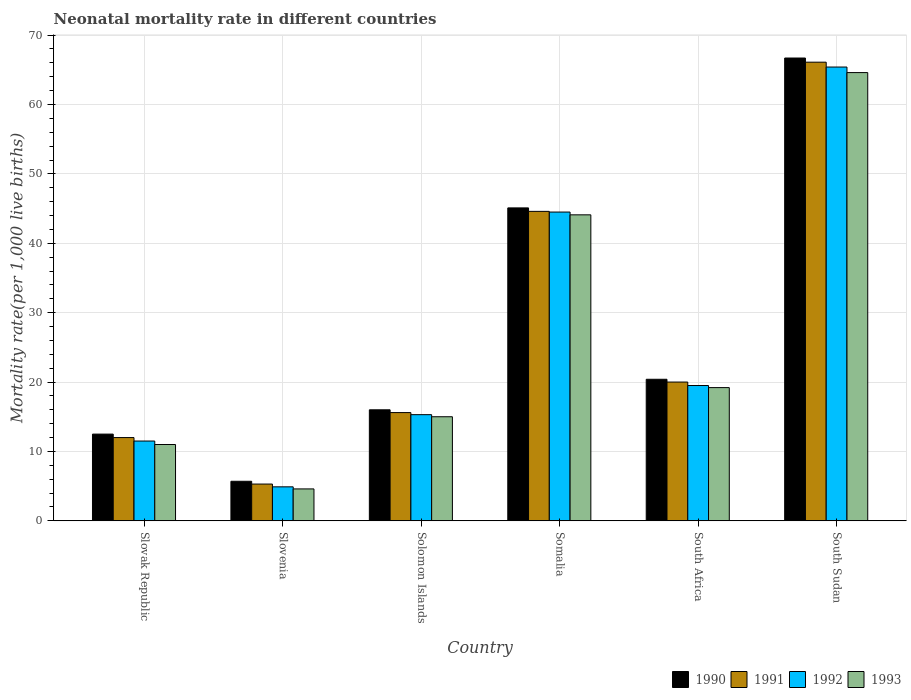How many different coloured bars are there?
Give a very brief answer. 4. Are the number of bars per tick equal to the number of legend labels?
Your answer should be very brief. Yes. How many bars are there on the 2nd tick from the left?
Make the answer very short. 4. How many bars are there on the 6th tick from the right?
Provide a short and direct response. 4. What is the label of the 4th group of bars from the left?
Your answer should be very brief. Somalia. In how many cases, is the number of bars for a given country not equal to the number of legend labels?
Offer a very short reply. 0. Across all countries, what is the maximum neonatal mortality rate in 1990?
Your answer should be very brief. 66.7. Across all countries, what is the minimum neonatal mortality rate in 1993?
Your answer should be compact. 4.6. In which country was the neonatal mortality rate in 1992 maximum?
Your answer should be compact. South Sudan. In which country was the neonatal mortality rate in 1991 minimum?
Offer a very short reply. Slovenia. What is the total neonatal mortality rate in 1990 in the graph?
Ensure brevity in your answer.  166.4. What is the difference between the neonatal mortality rate in 1991 in Slovenia and that in Somalia?
Keep it short and to the point. -39.3. What is the difference between the neonatal mortality rate in 1992 in Slovenia and the neonatal mortality rate in 1991 in South Sudan?
Provide a succinct answer. -61.2. What is the average neonatal mortality rate in 1992 per country?
Give a very brief answer. 26.85. What is the difference between the neonatal mortality rate of/in 1992 and neonatal mortality rate of/in 1990 in South Africa?
Ensure brevity in your answer.  -0.9. In how many countries, is the neonatal mortality rate in 1992 greater than 58?
Offer a terse response. 1. What is the ratio of the neonatal mortality rate in 1991 in Slovak Republic to that in South Sudan?
Ensure brevity in your answer.  0.18. Is the neonatal mortality rate in 1990 in Slovak Republic less than that in Slovenia?
Make the answer very short. No. Is the difference between the neonatal mortality rate in 1992 in South Africa and South Sudan greater than the difference between the neonatal mortality rate in 1990 in South Africa and South Sudan?
Ensure brevity in your answer.  Yes. What is the difference between the highest and the second highest neonatal mortality rate in 1993?
Offer a terse response. 45.4. What is the difference between the highest and the lowest neonatal mortality rate in 1992?
Your answer should be compact. 60.5. Is the sum of the neonatal mortality rate in 1990 in Slovenia and Somalia greater than the maximum neonatal mortality rate in 1991 across all countries?
Keep it short and to the point. No. Is it the case that in every country, the sum of the neonatal mortality rate in 1993 and neonatal mortality rate in 1992 is greater than the sum of neonatal mortality rate in 1991 and neonatal mortality rate in 1990?
Ensure brevity in your answer.  No. Is it the case that in every country, the sum of the neonatal mortality rate in 1990 and neonatal mortality rate in 1993 is greater than the neonatal mortality rate in 1992?
Ensure brevity in your answer.  Yes. Are all the bars in the graph horizontal?
Provide a short and direct response. No. What is the difference between two consecutive major ticks on the Y-axis?
Your answer should be compact. 10. Where does the legend appear in the graph?
Make the answer very short. Bottom right. What is the title of the graph?
Offer a terse response. Neonatal mortality rate in different countries. What is the label or title of the Y-axis?
Your answer should be very brief. Mortality rate(per 1,0 live births). What is the Mortality rate(per 1,000 live births) of 1991 in Slovenia?
Offer a very short reply. 5.3. What is the Mortality rate(per 1,000 live births) of 1992 in Slovenia?
Ensure brevity in your answer.  4.9. What is the Mortality rate(per 1,000 live births) in 1990 in Solomon Islands?
Keep it short and to the point. 16. What is the Mortality rate(per 1,000 live births) of 1990 in Somalia?
Ensure brevity in your answer.  45.1. What is the Mortality rate(per 1,000 live births) of 1991 in Somalia?
Offer a very short reply. 44.6. What is the Mortality rate(per 1,000 live births) in 1992 in Somalia?
Provide a short and direct response. 44.5. What is the Mortality rate(per 1,000 live births) in 1993 in Somalia?
Your answer should be very brief. 44.1. What is the Mortality rate(per 1,000 live births) in 1990 in South Africa?
Make the answer very short. 20.4. What is the Mortality rate(per 1,000 live births) of 1992 in South Africa?
Ensure brevity in your answer.  19.5. What is the Mortality rate(per 1,000 live births) of 1990 in South Sudan?
Keep it short and to the point. 66.7. What is the Mortality rate(per 1,000 live births) of 1991 in South Sudan?
Give a very brief answer. 66.1. What is the Mortality rate(per 1,000 live births) of 1992 in South Sudan?
Offer a very short reply. 65.4. What is the Mortality rate(per 1,000 live births) in 1993 in South Sudan?
Offer a very short reply. 64.6. Across all countries, what is the maximum Mortality rate(per 1,000 live births) of 1990?
Keep it short and to the point. 66.7. Across all countries, what is the maximum Mortality rate(per 1,000 live births) in 1991?
Ensure brevity in your answer.  66.1. Across all countries, what is the maximum Mortality rate(per 1,000 live births) of 1992?
Give a very brief answer. 65.4. Across all countries, what is the maximum Mortality rate(per 1,000 live births) of 1993?
Ensure brevity in your answer.  64.6. Across all countries, what is the minimum Mortality rate(per 1,000 live births) in 1990?
Your answer should be very brief. 5.7. What is the total Mortality rate(per 1,000 live births) of 1990 in the graph?
Give a very brief answer. 166.4. What is the total Mortality rate(per 1,000 live births) of 1991 in the graph?
Make the answer very short. 163.6. What is the total Mortality rate(per 1,000 live births) of 1992 in the graph?
Offer a very short reply. 161.1. What is the total Mortality rate(per 1,000 live births) in 1993 in the graph?
Provide a succinct answer. 158.5. What is the difference between the Mortality rate(per 1,000 live births) in 1990 in Slovak Republic and that in Slovenia?
Provide a succinct answer. 6.8. What is the difference between the Mortality rate(per 1,000 live births) of 1990 in Slovak Republic and that in Somalia?
Your answer should be compact. -32.6. What is the difference between the Mortality rate(per 1,000 live births) of 1991 in Slovak Republic and that in Somalia?
Your response must be concise. -32.6. What is the difference between the Mortality rate(per 1,000 live births) in 1992 in Slovak Republic and that in Somalia?
Provide a short and direct response. -33. What is the difference between the Mortality rate(per 1,000 live births) in 1993 in Slovak Republic and that in Somalia?
Offer a terse response. -33.1. What is the difference between the Mortality rate(per 1,000 live births) of 1993 in Slovak Republic and that in South Africa?
Your answer should be very brief. -8.2. What is the difference between the Mortality rate(per 1,000 live births) in 1990 in Slovak Republic and that in South Sudan?
Make the answer very short. -54.2. What is the difference between the Mortality rate(per 1,000 live births) of 1991 in Slovak Republic and that in South Sudan?
Offer a terse response. -54.1. What is the difference between the Mortality rate(per 1,000 live births) in 1992 in Slovak Republic and that in South Sudan?
Your answer should be compact. -53.9. What is the difference between the Mortality rate(per 1,000 live births) in 1993 in Slovak Republic and that in South Sudan?
Give a very brief answer. -53.6. What is the difference between the Mortality rate(per 1,000 live births) in 1991 in Slovenia and that in Solomon Islands?
Ensure brevity in your answer.  -10.3. What is the difference between the Mortality rate(per 1,000 live births) of 1993 in Slovenia and that in Solomon Islands?
Provide a short and direct response. -10.4. What is the difference between the Mortality rate(per 1,000 live births) of 1990 in Slovenia and that in Somalia?
Provide a short and direct response. -39.4. What is the difference between the Mortality rate(per 1,000 live births) of 1991 in Slovenia and that in Somalia?
Your answer should be very brief. -39.3. What is the difference between the Mortality rate(per 1,000 live births) of 1992 in Slovenia and that in Somalia?
Provide a short and direct response. -39.6. What is the difference between the Mortality rate(per 1,000 live births) in 1993 in Slovenia and that in Somalia?
Your response must be concise. -39.5. What is the difference between the Mortality rate(per 1,000 live births) of 1990 in Slovenia and that in South Africa?
Give a very brief answer. -14.7. What is the difference between the Mortality rate(per 1,000 live births) of 1991 in Slovenia and that in South Africa?
Give a very brief answer. -14.7. What is the difference between the Mortality rate(per 1,000 live births) of 1992 in Slovenia and that in South Africa?
Make the answer very short. -14.6. What is the difference between the Mortality rate(per 1,000 live births) of 1993 in Slovenia and that in South Africa?
Offer a terse response. -14.6. What is the difference between the Mortality rate(per 1,000 live births) in 1990 in Slovenia and that in South Sudan?
Offer a very short reply. -61. What is the difference between the Mortality rate(per 1,000 live births) in 1991 in Slovenia and that in South Sudan?
Keep it short and to the point. -60.8. What is the difference between the Mortality rate(per 1,000 live births) in 1992 in Slovenia and that in South Sudan?
Ensure brevity in your answer.  -60.5. What is the difference between the Mortality rate(per 1,000 live births) of 1993 in Slovenia and that in South Sudan?
Ensure brevity in your answer.  -60. What is the difference between the Mortality rate(per 1,000 live births) in 1990 in Solomon Islands and that in Somalia?
Your response must be concise. -29.1. What is the difference between the Mortality rate(per 1,000 live births) in 1992 in Solomon Islands and that in Somalia?
Provide a short and direct response. -29.2. What is the difference between the Mortality rate(per 1,000 live births) in 1993 in Solomon Islands and that in Somalia?
Offer a terse response. -29.1. What is the difference between the Mortality rate(per 1,000 live births) of 1991 in Solomon Islands and that in South Africa?
Offer a terse response. -4.4. What is the difference between the Mortality rate(per 1,000 live births) of 1992 in Solomon Islands and that in South Africa?
Offer a very short reply. -4.2. What is the difference between the Mortality rate(per 1,000 live births) of 1993 in Solomon Islands and that in South Africa?
Offer a terse response. -4.2. What is the difference between the Mortality rate(per 1,000 live births) in 1990 in Solomon Islands and that in South Sudan?
Offer a very short reply. -50.7. What is the difference between the Mortality rate(per 1,000 live births) of 1991 in Solomon Islands and that in South Sudan?
Your answer should be very brief. -50.5. What is the difference between the Mortality rate(per 1,000 live births) in 1992 in Solomon Islands and that in South Sudan?
Your answer should be compact. -50.1. What is the difference between the Mortality rate(per 1,000 live births) of 1993 in Solomon Islands and that in South Sudan?
Provide a succinct answer. -49.6. What is the difference between the Mortality rate(per 1,000 live births) of 1990 in Somalia and that in South Africa?
Your answer should be very brief. 24.7. What is the difference between the Mortality rate(per 1,000 live births) in 1991 in Somalia and that in South Africa?
Keep it short and to the point. 24.6. What is the difference between the Mortality rate(per 1,000 live births) of 1993 in Somalia and that in South Africa?
Make the answer very short. 24.9. What is the difference between the Mortality rate(per 1,000 live births) in 1990 in Somalia and that in South Sudan?
Offer a terse response. -21.6. What is the difference between the Mortality rate(per 1,000 live births) of 1991 in Somalia and that in South Sudan?
Make the answer very short. -21.5. What is the difference between the Mortality rate(per 1,000 live births) in 1992 in Somalia and that in South Sudan?
Offer a very short reply. -20.9. What is the difference between the Mortality rate(per 1,000 live births) of 1993 in Somalia and that in South Sudan?
Make the answer very short. -20.5. What is the difference between the Mortality rate(per 1,000 live births) of 1990 in South Africa and that in South Sudan?
Make the answer very short. -46.3. What is the difference between the Mortality rate(per 1,000 live births) of 1991 in South Africa and that in South Sudan?
Keep it short and to the point. -46.1. What is the difference between the Mortality rate(per 1,000 live births) of 1992 in South Africa and that in South Sudan?
Ensure brevity in your answer.  -45.9. What is the difference between the Mortality rate(per 1,000 live births) in 1993 in South Africa and that in South Sudan?
Your answer should be compact. -45.4. What is the difference between the Mortality rate(per 1,000 live births) in 1990 in Slovak Republic and the Mortality rate(per 1,000 live births) in 1992 in Slovenia?
Provide a short and direct response. 7.6. What is the difference between the Mortality rate(per 1,000 live births) in 1991 in Slovak Republic and the Mortality rate(per 1,000 live births) in 1992 in Slovenia?
Provide a short and direct response. 7.1. What is the difference between the Mortality rate(per 1,000 live births) in 1991 in Slovak Republic and the Mortality rate(per 1,000 live births) in 1993 in Slovenia?
Provide a succinct answer. 7.4. What is the difference between the Mortality rate(per 1,000 live births) of 1990 in Slovak Republic and the Mortality rate(per 1,000 live births) of 1991 in Solomon Islands?
Offer a terse response. -3.1. What is the difference between the Mortality rate(per 1,000 live births) of 1990 in Slovak Republic and the Mortality rate(per 1,000 live births) of 1992 in Solomon Islands?
Offer a terse response. -2.8. What is the difference between the Mortality rate(per 1,000 live births) in 1991 in Slovak Republic and the Mortality rate(per 1,000 live births) in 1992 in Solomon Islands?
Your response must be concise. -3.3. What is the difference between the Mortality rate(per 1,000 live births) in 1991 in Slovak Republic and the Mortality rate(per 1,000 live births) in 1993 in Solomon Islands?
Ensure brevity in your answer.  -3. What is the difference between the Mortality rate(per 1,000 live births) of 1992 in Slovak Republic and the Mortality rate(per 1,000 live births) of 1993 in Solomon Islands?
Your answer should be compact. -3.5. What is the difference between the Mortality rate(per 1,000 live births) in 1990 in Slovak Republic and the Mortality rate(per 1,000 live births) in 1991 in Somalia?
Your response must be concise. -32.1. What is the difference between the Mortality rate(per 1,000 live births) in 1990 in Slovak Republic and the Mortality rate(per 1,000 live births) in 1992 in Somalia?
Keep it short and to the point. -32. What is the difference between the Mortality rate(per 1,000 live births) of 1990 in Slovak Republic and the Mortality rate(per 1,000 live births) of 1993 in Somalia?
Provide a succinct answer. -31.6. What is the difference between the Mortality rate(per 1,000 live births) of 1991 in Slovak Republic and the Mortality rate(per 1,000 live births) of 1992 in Somalia?
Provide a succinct answer. -32.5. What is the difference between the Mortality rate(per 1,000 live births) in 1991 in Slovak Republic and the Mortality rate(per 1,000 live births) in 1993 in Somalia?
Offer a very short reply. -32.1. What is the difference between the Mortality rate(per 1,000 live births) of 1992 in Slovak Republic and the Mortality rate(per 1,000 live births) of 1993 in Somalia?
Give a very brief answer. -32.6. What is the difference between the Mortality rate(per 1,000 live births) in 1990 in Slovak Republic and the Mortality rate(per 1,000 live births) in 1992 in South Africa?
Offer a terse response. -7. What is the difference between the Mortality rate(per 1,000 live births) in 1990 in Slovak Republic and the Mortality rate(per 1,000 live births) in 1991 in South Sudan?
Ensure brevity in your answer.  -53.6. What is the difference between the Mortality rate(per 1,000 live births) in 1990 in Slovak Republic and the Mortality rate(per 1,000 live births) in 1992 in South Sudan?
Give a very brief answer. -52.9. What is the difference between the Mortality rate(per 1,000 live births) of 1990 in Slovak Republic and the Mortality rate(per 1,000 live births) of 1993 in South Sudan?
Make the answer very short. -52.1. What is the difference between the Mortality rate(per 1,000 live births) in 1991 in Slovak Republic and the Mortality rate(per 1,000 live births) in 1992 in South Sudan?
Offer a terse response. -53.4. What is the difference between the Mortality rate(per 1,000 live births) in 1991 in Slovak Republic and the Mortality rate(per 1,000 live births) in 1993 in South Sudan?
Ensure brevity in your answer.  -52.6. What is the difference between the Mortality rate(per 1,000 live births) in 1992 in Slovak Republic and the Mortality rate(per 1,000 live births) in 1993 in South Sudan?
Provide a short and direct response. -53.1. What is the difference between the Mortality rate(per 1,000 live births) of 1990 in Slovenia and the Mortality rate(per 1,000 live births) of 1993 in Solomon Islands?
Offer a very short reply. -9.3. What is the difference between the Mortality rate(per 1,000 live births) in 1991 in Slovenia and the Mortality rate(per 1,000 live births) in 1992 in Solomon Islands?
Your answer should be very brief. -10. What is the difference between the Mortality rate(per 1,000 live births) in 1992 in Slovenia and the Mortality rate(per 1,000 live births) in 1993 in Solomon Islands?
Your answer should be compact. -10.1. What is the difference between the Mortality rate(per 1,000 live births) in 1990 in Slovenia and the Mortality rate(per 1,000 live births) in 1991 in Somalia?
Your response must be concise. -38.9. What is the difference between the Mortality rate(per 1,000 live births) in 1990 in Slovenia and the Mortality rate(per 1,000 live births) in 1992 in Somalia?
Your answer should be very brief. -38.8. What is the difference between the Mortality rate(per 1,000 live births) of 1990 in Slovenia and the Mortality rate(per 1,000 live births) of 1993 in Somalia?
Ensure brevity in your answer.  -38.4. What is the difference between the Mortality rate(per 1,000 live births) of 1991 in Slovenia and the Mortality rate(per 1,000 live births) of 1992 in Somalia?
Your response must be concise. -39.2. What is the difference between the Mortality rate(per 1,000 live births) of 1991 in Slovenia and the Mortality rate(per 1,000 live births) of 1993 in Somalia?
Provide a short and direct response. -38.8. What is the difference between the Mortality rate(per 1,000 live births) in 1992 in Slovenia and the Mortality rate(per 1,000 live births) in 1993 in Somalia?
Your answer should be compact. -39.2. What is the difference between the Mortality rate(per 1,000 live births) of 1990 in Slovenia and the Mortality rate(per 1,000 live births) of 1991 in South Africa?
Offer a very short reply. -14.3. What is the difference between the Mortality rate(per 1,000 live births) of 1991 in Slovenia and the Mortality rate(per 1,000 live births) of 1993 in South Africa?
Your answer should be compact. -13.9. What is the difference between the Mortality rate(per 1,000 live births) of 1992 in Slovenia and the Mortality rate(per 1,000 live births) of 1993 in South Africa?
Offer a terse response. -14.3. What is the difference between the Mortality rate(per 1,000 live births) of 1990 in Slovenia and the Mortality rate(per 1,000 live births) of 1991 in South Sudan?
Your answer should be very brief. -60.4. What is the difference between the Mortality rate(per 1,000 live births) in 1990 in Slovenia and the Mortality rate(per 1,000 live births) in 1992 in South Sudan?
Keep it short and to the point. -59.7. What is the difference between the Mortality rate(per 1,000 live births) of 1990 in Slovenia and the Mortality rate(per 1,000 live births) of 1993 in South Sudan?
Provide a short and direct response. -58.9. What is the difference between the Mortality rate(per 1,000 live births) of 1991 in Slovenia and the Mortality rate(per 1,000 live births) of 1992 in South Sudan?
Ensure brevity in your answer.  -60.1. What is the difference between the Mortality rate(per 1,000 live births) in 1991 in Slovenia and the Mortality rate(per 1,000 live births) in 1993 in South Sudan?
Make the answer very short. -59.3. What is the difference between the Mortality rate(per 1,000 live births) in 1992 in Slovenia and the Mortality rate(per 1,000 live births) in 1993 in South Sudan?
Ensure brevity in your answer.  -59.7. What is the difference between the Mortality rate(per 1,000 live births) of 1990 in Solomon Islands and the Mortality rate(per 1,000 live births) of 1991 in Somalia?
Keep it short and to the point. -28.6. What is the difference between the Mortality rate(per 1,000 live births) in 1990 in Solomon Islands and the Mortality rate(per 1,000 live births) in 1992 in Somalia?
Your response must be concise. -28.5. What is the difference between the Mortality rate(per 1,000 live births) of 1990 in Solomon Islands and the Mortality rate(per 1,000 live births) of 1993 in Somalia?
Ensure brevity in your answer.  -28.1. What is the difference between the Mortality rate(per 1,000 live births) in 1991 in Solomon Islands and the Mortality rate(per 1,000 live births) in 1992 in Somalia?
Your answer should be compact. -28.9. What is the difference between the Mortality rate(per 1,000 live births) of 1991 in Solomon Islands and the Mortality rate(per 1,000 live births) of 1993 in Somalia?
Make the answer very short. -28.5. What is the difference between the Mortality rate(per 1,000 live births) of 1992 in Solomon Islands and the Mortality rate(per 1,000 live births) of 1993 in Somalia?
Offer a terse response. -28.8. What is the difference between the Mortality rate(per 1,000 live births) of 1990 in Solomon Islands and the Mortality rate(per 1,000 live births) of 1991 in South Africa?
Keep it short and to the point. -4. What is the difference between the Mortality rate(per 1,000 live births) in 1990 in Solomon Islands and the Mortality rate(per 1,000 live births) in 1992 in South Africa?
Provide a short and direct response. -3.5. What is the difference between the Mortality rate(per 1,000 live births) of 1991 in Solomon Islands and the Mortality rate(per 1,000 live births) of 1992 in South Africa?
Your answer should be very brief. -3.9. What is the difference between the Mortality rate(per 1,000 live births) of 1991 in Solomon Islands and the Mortality rate(per 1,000 live births) of 1993 in South Africa?
Offer a terse response. -3.6. What is the difference between the Mortality rate(per 1,000 live births) of 1990 in Solomon Islands and the Mortality rate(per 1,000 live births) of 1991 in South Sudan?
Give a very brief answer. -50.1. What is the difference between the Mortality rate(per 1,000 live births) in 1990 in Solomon Islands and the Mortality rate(per 1,000 live births) in 1992 in South Sudan?
Ensure brevity in your answer.  -49.4. What is the difference between the Mortality rate(per 1,000 live births) of 1990 in Solomon Islands and the Mortality rate(per 1,000 live births) of 1993 in South Sudan?
Provide a short and direct response. -48.6. What is the difference between the Mortality rate(per 1,000 live births) of 1991 in Solomon Islands and the Mortality rate(per 1,000 live births) of 1992 in South Sudan?
Give a very brief answer. -49.8. What is the difference between the Mortality rate(per 1,000 live births) in 1991 in Solomon Islands and the Mortality rate(per 1,000 live births) in 1993 in South Sudan?
Give a very brief answer. -49. What is the difference between the Mortality rate(per 1,000 live births) of 1992 in Solomon Islands and the Mortality rate(per 1,000 live births) of 1993 in South Sudan?
Your response must be concise. -49.3. What is the difference between the Mortality rate(per 1,000 live births) of 1990 in Somalia and the Mortality rate(per 1,000 live births) of 1991 in South Africa?
Give a very brief answer. 25.1. What is the difference between the Mortality rate(per 1,000 live births) in 1990 in Somalia and the Mortality rate(per 1,000 live births) in 1992 in South Africa?
Your answer should be compact. 25.6. What is the difference between the Mortality rate(per 1,000 live births) of 1990 in Somalia and the Mortality rate(per 1,000 live births) of 1993 in South Africa?
Your answer should be very brief. 25.9. What is the difference between the Mortality rate(per 1,000 live births) in 1991 in Somalia and the Mortality rate(per 1,000 live births) in 1992 in South Africa?
Your response must be concise. 25.1. What is the difference between the Mortality rate(per 1,000 live births) in 1991 in Somalia and the Mortality rate(per 1,000 live births) in 1993 in South Africa?
Offer a terse response. 25.4. What is the difference between the Mortality rate(per 1,000 live births) of 1992 in Somalia and the Mortality rate(per 1,000 live births) of 1993 in South Africa?
Give a very brief answer. 25.3. What is the difference between the Mortality rate(per 1,000 live births) in 1990 in Somalia and the Mortality rate(per 1,000 live births) in 1992 in South Sudan?
Provide a short and direct response. -20.3. What is the difference between the Mortality rate(per 1,000 live births) in 1990 in Somalia and the Mortality rate(per 1,000 live births) in 1993 in South Sudan?
Provide a succinct answer. -19.5. What is the difference between the Mortality rate(per 1,000 live births) of 1991 in Somalia and the Mortality rate(per 1,000 live births) of 1992 in South Sudan?
Provide a succinct answer. -20.8. What is the difference between the Mortality rate(per 1,000 live births) of 1991 in Somalia and the Mortality rate(per 1,000 live births) of 1993 in South Sudan?
Keep it short and to the point. -20. What is the difference between the Mortality rate(per 1,000 live births) in 1992 in Somalia and the Mortality rate(per 1,000 live births) in 1993 in South Sudan?
Provide a short and direct response. -20.1. What is the difference between the Mortality rate(per 1,000 live births) in 1990 in South Africa and the Mortality rate(per 1,000 live births) in 1991 in South Sudan?
Offer a very short reply. -45.7. What is the difference between the Mortality rate(per 1,000 live births) of 1990 in South Africa and the Mortality rate(per 1,000 live births) of 1992 in South Sudan?
Your response must be concise. -45. What is the difference between the Mortality rate(per 1,000 live births) of 1990 in South Africa and the Mortality rate(per 1,000 live births) of 1993 in South Sudan?
Keep it short and to the point. -44.2. What is the difference between the Mortality rate(per 1,000 live births) in 1991 in South Africa and the Mortality rate(per 1,000 live births) in 1992 in South Sudan?
Ensure brevity in your answer.  -45.4. What is the difference between the Mortality rate(per 1,000 live births) in 1991 in South Africa and the Mortality rate(per 1,000 live births) in 1993 in South Sudan?
Provide a short and direct response. -44.6. What is the difference between the Mortality rate(per 1,000 live births) of 1992 in South Africa and the Mortality rate(per 1,000 live births) of 1993 in South Sudan?
Keep it short and to the point. -45.1. What is the average Mortality rate(per 1,000 live births) in 1990 per country?
Your response must be concise. 27.73. What is the average Mortality rate(per 1,000 live births) of 1991 per country?
Provide a succinct answer. 27.27. What is the average Mortality rate(per 1,000 live births) of 1992 per country?
Your response must be concise. 26.85. What is the average Mortality rate(per 1,000 live births) in 1993 per country?
Your response must be concise. 26.42. What is the difference between the Mortality rate(per 1,000 live births) in 1990 and Mortality rate(per 1,000 live births) in 1991 in Slovak Republic?
Your answer should be very brief. 0.5. What is the difference between the Mortality rate(per 1,000 live births) in 1990 and Mortality rate(per 1,000 live births) in 1992 in Slovak Republic?
Provide a short and direct response. 1. What is the difference between the Mortality rate(per 1,000 live births) in 1991 and Mortality rate(per 1,000 live births) in 1992 in Slovak Republic?
Offer a terse response. 0.5. What is the difference between the Mortality rate(per 1,000 live births) in 1991 and Mortality rate(per 1,000 live births) in 1993 in Slovak Republic?
Ensure brevity in your answer.  1. What is the difference between the Mortality rate(per 1,000 live births) in 1990 and Mortality rate(per 1,000 live births) in 1991 in Slovenia?
Your response must be concise. 0.4. What is the difference between the Mortality rate(per 1,000 live births) in 1991 and Mortality rate(per 1,000 live births) in 1992 in Slovenia?
Make the answer very short. 0.4. What is the difference between the Mortality rate(per 1,000 live births) of 1991 and Mortality rate(per 1,000 live births) of 1993 in Slovenia?
Make the answer very short. 0.7. What is the difference between the Mortality rate(per 1,000 live births) of 1990 and Mortality rate(per 1,000 live births) of 1991 in Solomon Islands?
Give a very brief answer. 0.4. What is the difference between the Mortality rate(per 1,000 live births) of 1991 and Mortality rate(per 1,000 live births) of 1992 in Solomon Islands?
Provide a short and direct response. 0.3. What is the difference between the Mortality rate(per 1,000 live births) of 1990 and Mortality rate(per 1,000 live births) of 1991 in Somalia?
Offer a terse response. 0.5. What is the difference between the Mortality rate(per 1,000 live births) of 1990 and Mortality rate(per 1,000 live births) of 1992 in Somalia?
Give a very brief answer. 0.6. What is the difference between the Mortality rate(per 1,000 live births) of 1990 and Mortality rate(per 1,000 live births) of 1993 in Somalia?
Your answer should be compact. 1. What is the difference between the Mortality rate(per 1,000 live births) in 1991 and Mortality rate(per 1,000 live births) in 1992 in Somalia?
Make the answer very short. 0.1. What is the difference between the Mortality rate(per 1,000 live births) in 1991 and Mortality rate(per 1,000 live births) in 1993 in Somalia?
Your response must be concise. 0.5. What is the difference between the Mortality rate(per 1,000 live births) in 1990 and Mortality rate(per 1,000 live births) in 1992 in South Africa?
Provide a short and direct response. 0.9. What is the difference between the Mortality rate(per 1,000 live births) of 1992 and Mortality rate(per 1,000 live births) of 1993 in South Africa?
Your response must be concise. 0.3. What is the difference between the Mortality rate(per 1,000 live births) of 1990 and Mortality rate(per 1,000 live births) of 1991 in South Sudan?
Provide a short and direct response. 0.6. What is the difference between the Mortality rate(per 1,000 live births) of 1990 and Mortality rate(per 1,000 live births) of 1993 in South Sudan?
Keep it short and to the point. 2.1. What is the difference between the Mortality rate(per 1,000 live births) in 1991 and Mortality rate(per 1,000 live births) in 1992 in South Sudan?
Provide a succinct answer. 0.7. What is the difference between the Mortality rate(per 1,000 live births) of 1992 and Mortality rate(per 1,000 live births) of 1993 in South Sudan?
Give a very brief answer. 0.8. What is the ratio of the Mortality rate(per 1,000 live births) of 1990 in Slovak Republic to that in Slovenia?
Offer a terse response. 2.19. What is the ratio of the Mortality rate(per 1,000 live births) in 1991 in Slovak Republic to that in Slovenia?
Keep it short and to the point. 2.26. What is the ratio of the Mortality rate(per 1,000 live births) in 1992 in Slovak Republic to that in Slovenia?
Offer a terse response. 2.35. What is the ratio of the Mortality rate(per 1,000 live births) in 1993 in Slovak Republic to that in Slovenia?
Keep it short and to the point. 2.39. What is the ratio of the Mortality rate(per 1,000 live births) in 1990 in Slovak Republic to that in Solomon Islands?
Your answer should be compact. 0.78. What is the ratio of the Mortality rate(per 1,000 live births) in 1991 in Slovak Republic to that in Solomon Islands?
Your answer should be very brief. 0.77. What is the ratio of the Mortality rate(per 1,000 live births) in 1992 in Slovak Republic to that in Solomon Islands?
Your answer should be compact. 0.75. What is the ratio of the Mortality rate(per 1,000 live births) in 1993 in Slovak Republic to that in Solomon Islands?
Offer a very short reply. 0.73. What is the ratio of the Mortality rate(per 1,000 live births) in 1990 in Slovak Republic to that in Somalia?
Ensure brevity in your answer.  0.28. What is the ratio of the Mortality rate(per 1,000 live births) in 1991 in Slovak Republic to that in Somalia?
Your answer should be compact. 0.27. What is the ratio of the Mortality rate(per 1,000 live births) in 1992 in Slovak Republic to that in Somalia?
Give a very brief answer. 0.26. What is the ratio of the Mortality rate(per 1,000 live births) of 1993 in Slovak Republic to that in Somalia?
Provide a succinct answer. 0.25. What is the ratio of the Mortality rate(per 1,000 live births) of 1990 in Slovak Republic to that in South Africa?
Keep it short and to the point. 0.61. What is the ratio of the Mortality rate(per 1,000 live births) of 1992 in Slovak Republic to that in South Africa?
Provide a succinct answer. 0.59. What is the ratio of the Mortality rate(per 1,000 live births) in 1993 in Slovak Republic to that in South Africa?
Offer a terse response. 0.57. What is the ratio of the Mortality rate(per 1,000 live births) of 1990 in Slovak Republic to that in South Sudan?
Give a very brief answer. 0.19. What is the ratio of the Mortality rate(per 1,000 live births) in 1991 in Slovak Republic to that in South Sudan?
Give a very brief answer. 0.18. What is the ratio of the Mortality rate(per 1,000 live births) in 1992 in Slovak Republic to that in South Sudan?
Your response must be concise. 0.18. What is the ratio of the Mortality rate(per 1,000 live births) in 1993 in Slovak Republic to that in South Sudan?
Offer a terse response. 0.17. What is the ratio of the Mortality rate(per 1,000 live births) of 1990 in Slovenia to that in Solomon Islands?
Give a very brief answer. 0.36. What is the ratio of the Mortality rate(per 1,000 live births) in 1991 in Slovenia to that in Solomon Islands?
Your response must be concise. 0.34. What is the ratio of the Mortality rate(per 1,000 live births) in 1992 in Slovenia to that in Solomon Islands?
Make the answer very short. 0.32. What is the ratio of the Mortality rate(per 1,000 live births) in 1993 in Slovenia to that in Solomon Islands?
Your answer should be very brief. 0.31. What is the ratio of the Mortality rate(per 1,000 live births) of 1990 in Slovenia to that in Somalia?
Provide a short and direct response. 0.13. What is the ratio of the Mortality rate(per 1,000 live births) in 1991 in Slovenia to that in Somalia?
Ensure brevity in your answer.  0.12. What is the ratio of the Mortality rate(per 1,000 live births) of 1992 in Slovenia to that in Somalia?
Provide a short and direct response. 0.11. What is the ratio of the Mortality rate(per 1,000 live births) of 1993 in Slovenia to that in Somalia?
Provide a short and direct response. 0.1. What is the ratio of the Mortality rate(per 1,000 live births) in 1990 in Slovenia to that in South Africa?
Give a very brief answer. 0.28. What is the ratio of the Mortality rate(per 1,000 live births) of 1991 in Slovenia to that in South Africa?
Provide a succinct answer. 0.27. What is the ratio of the Mortality rate(per 1,000 live births) of 1992 in Slovenia to that in South Africa?
Provide a succinct answer. 0.25. What is the ratio of the Mortality rate(per 1,000 live births) in 1993 in Slovenia to that in South Africa?
Ensure brevity in your answer.  0.24. What is the ratio of the Mortality rate(per 1,000 live births) of 1990 in Slovenia to that in South Sudan?
Offer a terse response. 0.09. What is the ratio of the Mortality rate(per 1,000 live births) of 1991 in Slovenia to that in South Sudan?
Provide a short and direct response. 0.08. What is the ratio of the Mortality rate(per 1,000 live births) in 1992 in Slovenia to that in South Sudan?
Offer a very short reply. 0.07. What is the ratio of the Mortality rate(per 1,000 live births) in 1993 in Slovenia to that in South Sudan?
Ensure brevity in your answer.  0.07. What is the ratio of the Mortality rate(per 1,000 live births) of 1990 in Solomon Islands to that in Somalia?
Your answer should be compact. 0.35. What is the ratio of the Mortality rate(per 1,000 live births) in 1991 in Solomon Islands to that in Somalia?
Your answer should be very brief. 0.35. What is the ratio of the Mortality rate(per 1,000 live births) in 1992 in Solomon Islands to that in Somalia?
Your answer should be compact. 0.34. What is the ratio of the Mortality rate(per 1,000 live births) in 1993 in Solomon Islands to that in Somalia?
Your answer should be very brief. 0.34. What is the ratio of the Mortality rate(per 1,000 live births) of 1990 in Solomon Islands to that in South Africa?
Give a very brief answer. 0.78. What is the ratio of the Mortality rate(per 1,000 live births) of 1991 in Solomon Islands to that in South Africa?
Ensure brevity in your answer.  0.78. What is the ratio of the Mortality rate(per 1,000 live births) of 1992 in Solomon Islands to that in South Africa?
Your answer should be very brief. 0.78. What is the ratio of the Mortality rate(per 1,000 live births) in 1993 in Solomon Islands to that in South Africa?
Keep it short and to the point. 0.78. What is the ratio of the Mortality rate(per 1,000 live births) of 1990 in Solomon Islands to that in South Sudan?
Your answer should be compact. 0.24. What is the ratio of the Mortality rate(per 1,000 live births) in 1991 in Solomon Islands to that in South Sudan?
Make the answer very short. 0.24. What is the ratio of the Mortality rate(per 1,000 live births) of 1992 in Solomon Islands to that in South Sudan?
Keep it short and to the point. 0.23. What is the ratio of the Mortality rate(per 1,000 live births) of 1993 in Solomon Islands to that in South Sudan?
Give a very brief answer. 0.23. What is the ratio of the Mortality rate(per 1,000 live births) in 1990 in Somalia to that in South Africa?
Give a very brief answer. 2.21. What is the ratio of the Mortality rate(per 1,000 live births) in 1991 in Somalia to that in South Africa?
Offer a terse response. 2.23. What is the ratio of the Mortality rate(per 1,000 live births) of 1992 in Somalia to that in South Africa?
Give a very brief answer. 2.28. What is the ratio of the Mortality rate(per 1,000 live births) in 1993 in Somalia to that in South Africa?
Give a very brief answer. 2.3. What is the ratio of the Mortality rate(per 1,000 live births) of 1990 in Somalia to that in South Sudan?
Your response must be concise. 0.68. What is the ratio of the Mortality rate(per 1,000 live births) in 1991 in Somalia to that in South Sudan?
Give a very brief answer. 0.67. What is the ratio of the Mortality rate(per 1,000 live births) in 1992 in Somalia to that in South Sudan?
Provide a short and direct response. 0.68. What is the ratio of the Mortality rate(per 1,000 live births) in 1993 in Somalia to that in South Sudan?
Your answer should be very brief. 0.68. What is the ratio of the Mortality rate(per 1,000 live births) in 1990 in South Africa to that in South Sudan?
Keep it short and to the point. 0.31. What is the ratio of the Mortality rate(per 1,000 live births) of 1991 in South Africa to that in South Sudan?
Offer a terse response. 0.3. What is the ratio of the Mortality rate(per 1,000 live births) of 1992 in South Africa to that in South Sudan?
Make the answer very short. 0.3. What is the ratio of the Mortality rate(per 1,000 live births) of 1993 in South Africa to that in South Sudan?
Your answer should be very brief. 0.3. What is the difference between the highest and the second highest Mortality rate(per 1,000 live births) in 1990?
Make the answer very short. 21.6. What is the difference between the highest and the second highest Mortality rate(per 1,000 live births) of 1991?
Make the answer very short. 21.5. What is the difference between the highest and the second highest Mortality rate(per 1,000 live births) of 1992?
Your answer should be very brief. 20.9. What is the difference between the highest and the second highest Mortality rate(per 1,000 live births) in 1993?
Ensure brevity in your answer.  20.5. What is the difference between the highest and the lowest Mortality rate(per 1,000 live births) in 1991?
Your answer should be compact. 60.8. What is the difference between the highest and the lowest Mortality rate(per 1,000 live births) in 1992?
Provide a short and direct response. 60.5. What is the difference between the highest and the lowest Mortality rate(per 1,000 live births) of 1993?
Offer a terse response. 60. 